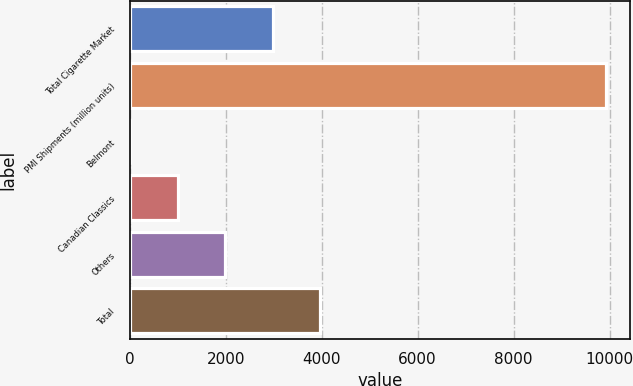Convert chart to OTSL. <chart><loc_0><loc_0><loc_500><loc_500><bar_chart><fcel>Total Cigarette Market<fcel>PMI Shipments (million units)<fcel>Belmont<fcel>Canadian Classics<fcel>Others<fcel>Total<nl><fcel>2980.11<fcel>9926<fcel>3.3<fcel>995.57<fcel>1987.84<fcel>3972.38<nl></chart> 